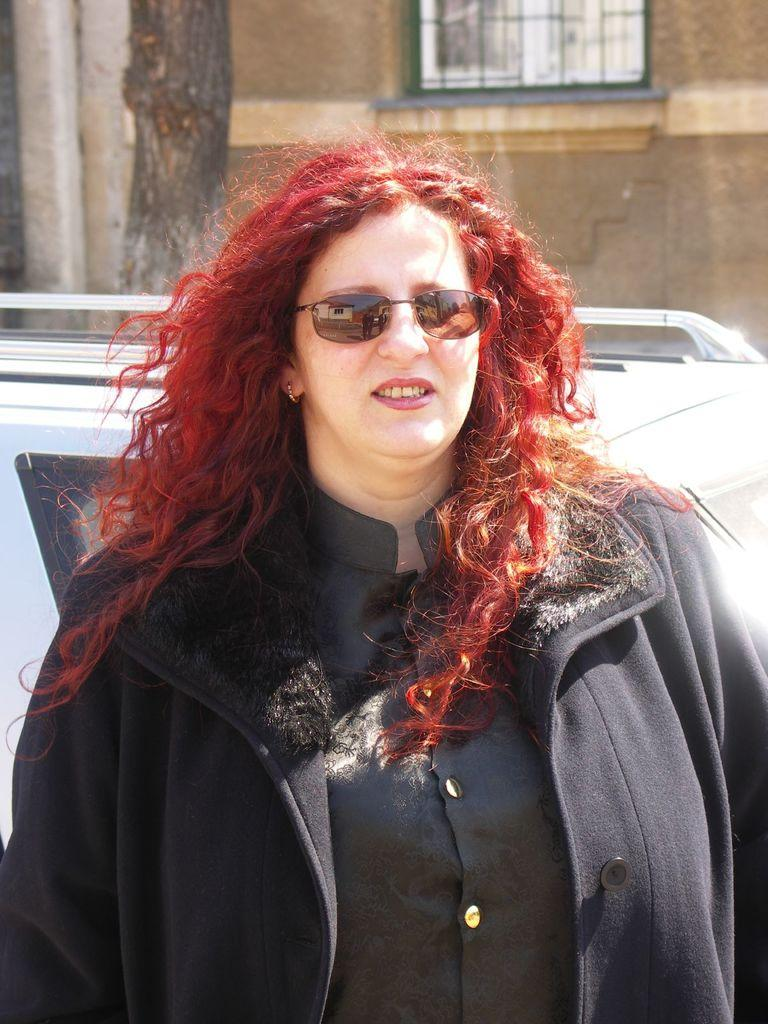Who is present in the image? There is a woman in the image. What is the woman wearing that is covering her eyes? The woman is wearing sunglasses. What is the woman's focus in the image? The woman is staring at something. What can be seen behind the woman? There is a car behind the woman. What is located behind the car? There is a tree behind the car. What is situated behind the tree? There is a building behind the tree. Can you see any cracks in the pavement near the woman in the image? There is no mention of a pavement or cracks in the image, so we cannot determine if there are any cracks present. 